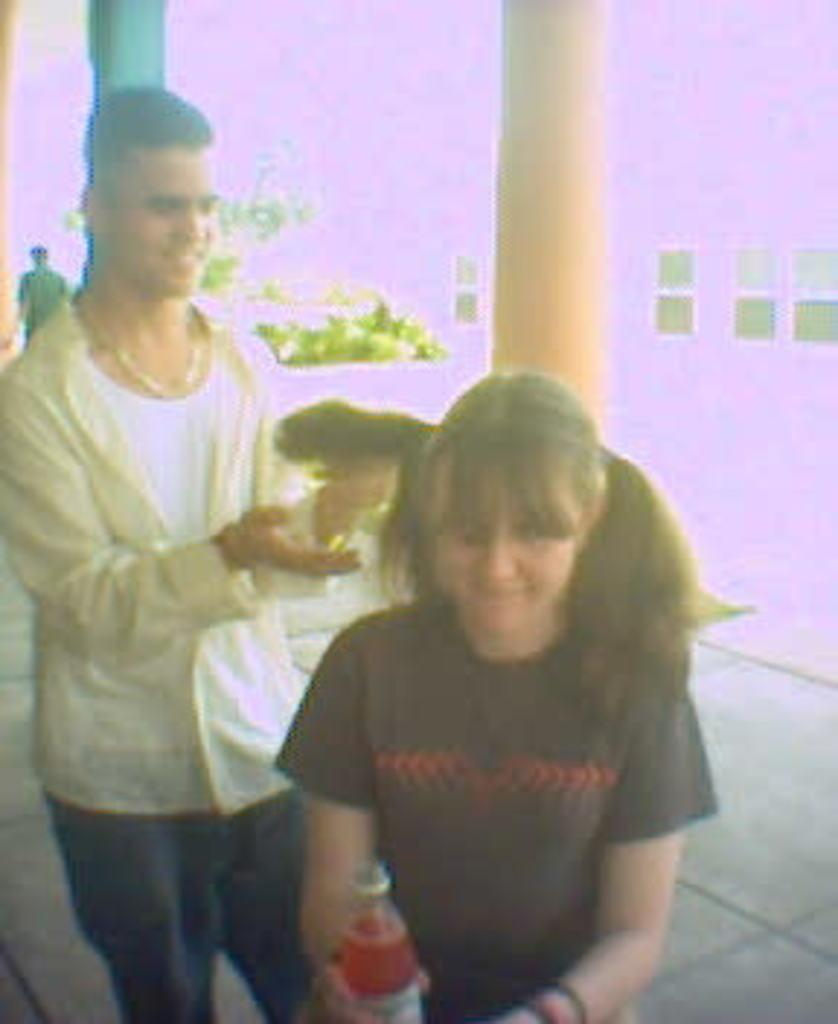Who is present in the image? There is a man and a woman in the image. What is the man doing in the image? The man is smiling in the image. What can be seen in the background of the image? There are pillars and plants in the background of the image. What type of meat is the man holding in the image? There is no meat present in the image; the man is simply smiling. 